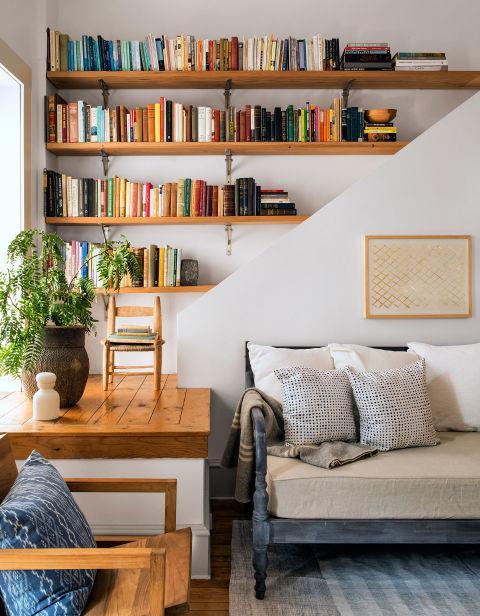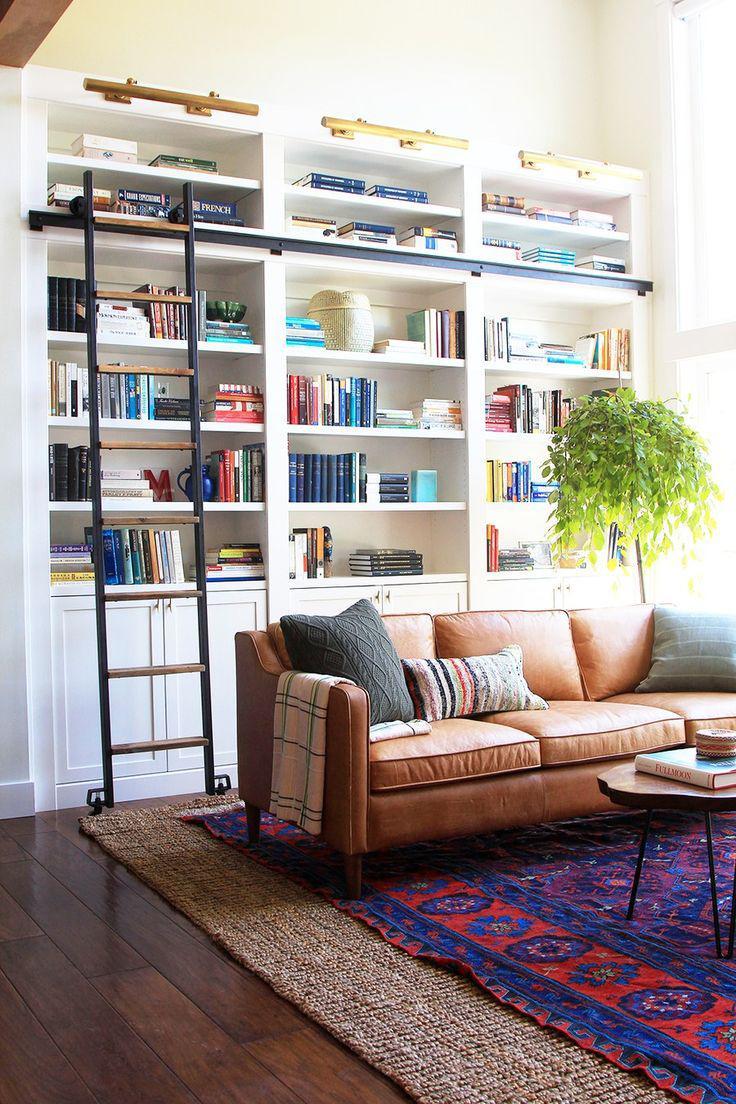The first image is the image on the left, the second image is the image on the right. Assess this claim about the two images: "A round coffee table is by a chair with a footstool in front of a wall-filling bookcase.". Correct or not? Answer yes or no. No. The first image is the image on the left, the second image is the image on the right. For the images displayed, is the sentence "The center table in one of the images holds a container with blooming flowers." factually correct? Answer yes or no. No. 